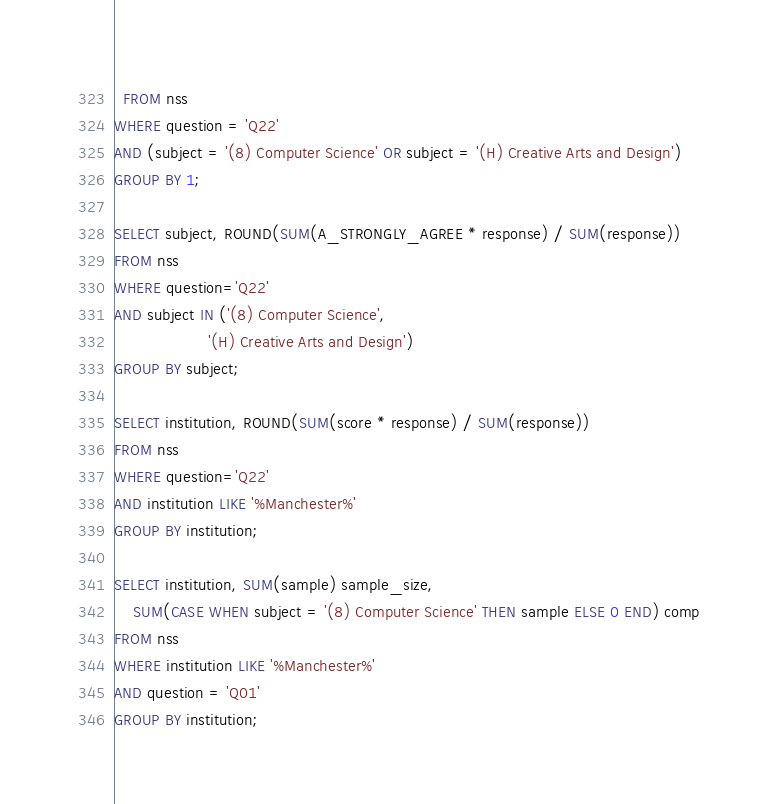<code> <loc_0><loc_0><loc_500><loc_500><_SQL_>  FROM nss
WHERE question = 'Q22'
AND (subject = '(8) Computer Science' OR subject = '(H) Creative Arts and Design')
GROUP BY 1;

SELECT subject, ROUND(SUM(A_STRONGLY_AGREE * response) / SUM(response))
FROM nss
WHERE question='Q22'
AND subject IN ('(8) Computer Science',
                    '(H) Creative Arts and Design')
GROUP BY subject;

SELECT institution, ROUND(SUM(score * response) / SUM(response))
FROM nss
WHERE question='Q22'
AND institution LIKE '%Manchester%'
GROUP BY institution;

SELECT institution, SUM(sample) sample_size, 
    SUM(CASE WHEN subject = '(8) Computer Science' THEN sample ELSE 0 END) comp
FROM nss
WHERE institution LIKE '%Manchester%'
AND question = 'Q01'
GROUP BY institution;</code> 